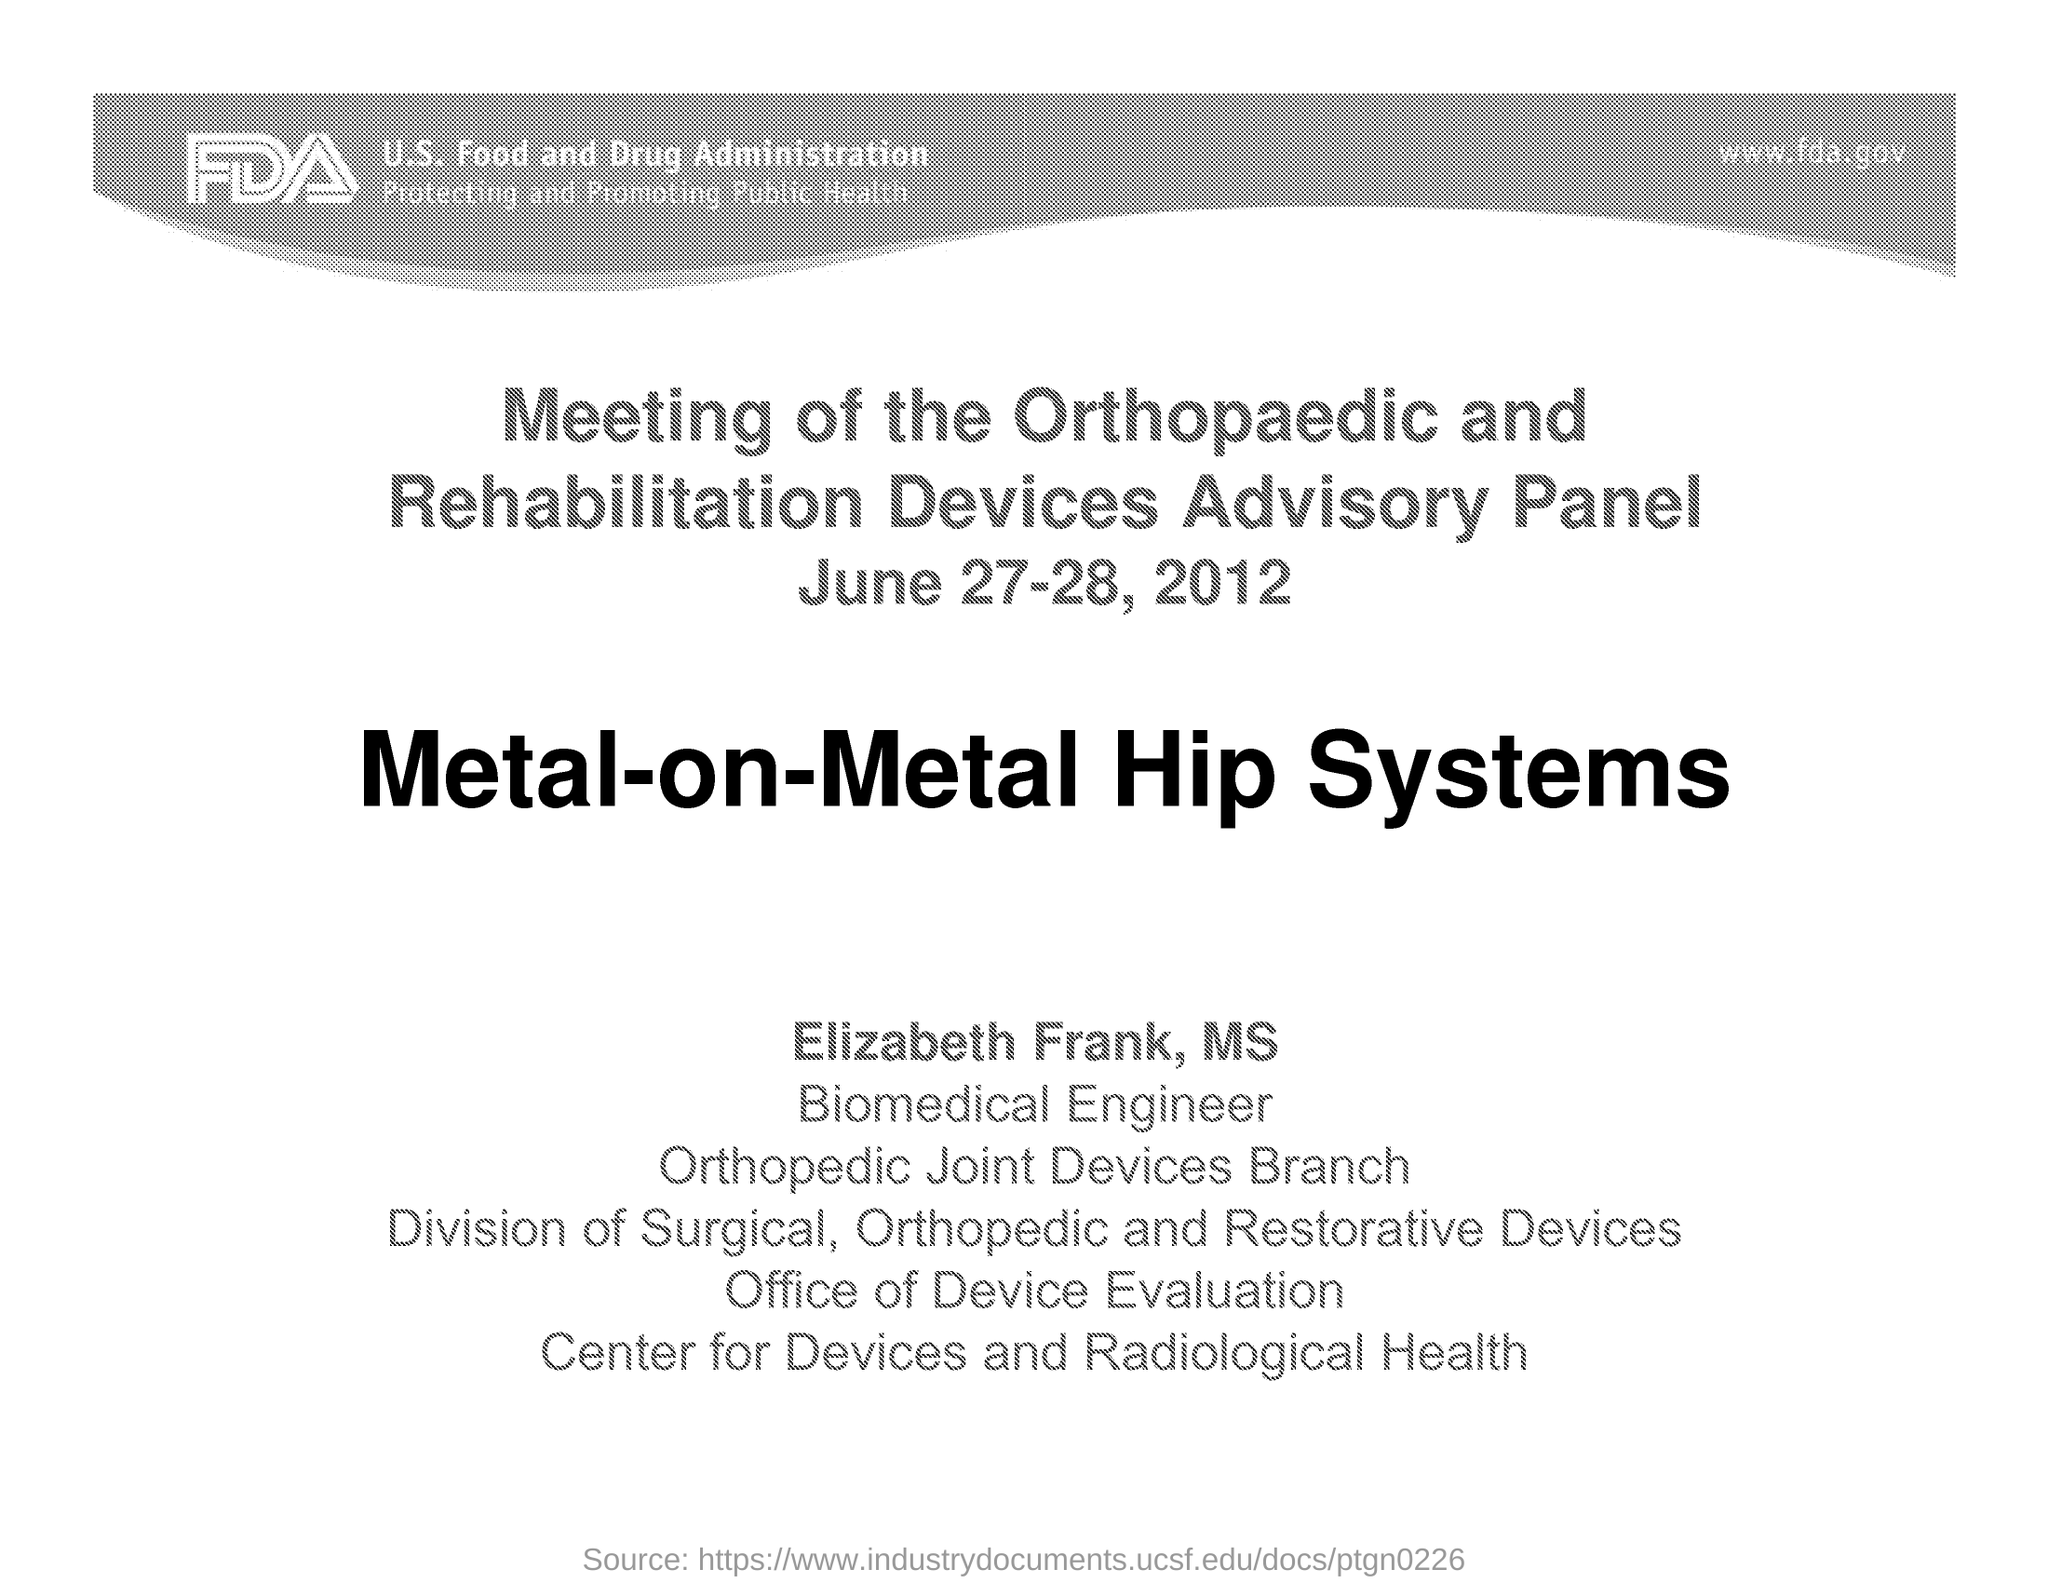When is the meeting of the Orthopaedic and Rehabilitation Devices Advisory Panel held?
Ensure brevity in your answer.  June 27-28, 2012. 